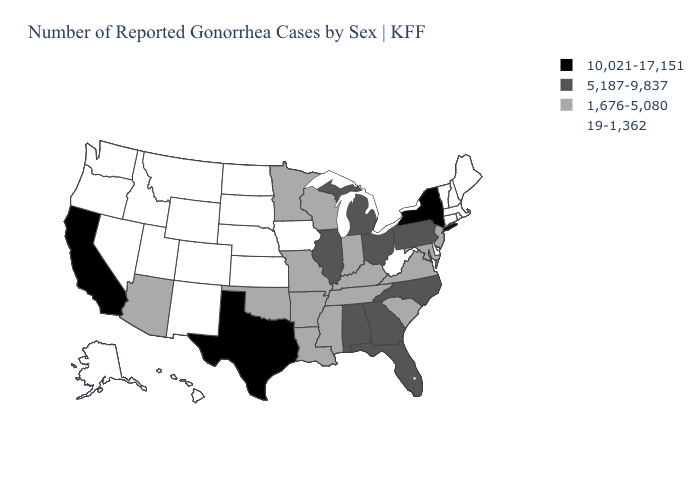Name the states that have a value in the range 1,676-5,080?
Concise answer only. Arizona, Arkansas, Indiana, Kentucky, Louisiana, Maryland, Minnesota, Mississippi, Missouri, New Jersey, Oklahoma, South Carolina, Tennessee, Virginia, Wisconsin. Does New York have the highest value in the USA?
Short answer required. Yes. Does Illinois have the highest value in the MidWest?
Concise answer only. Yes. Name the states that have a value in the range 5,187-9,837?
Concise answer only. Alabama, Florida, Georgia, Illinois, Michigan, North Carolina, Ohio, Pennsylvania. Name the states that have a value in the range 1,676-5,080?
Answer briefly. Arizona, Arkansas, Indiana, Kentucky, Louisiana, Maryland, Minnesota, Mississippi, Missouri, New Jersey, Oklahoma, South Carolina, Tennessee, Virginia, Wisconsin. What is the value of Alaska?
Short answer required. 19-1,362. What is the highest value in states that border Idaho?
Concise answer only. 19-1,362. Which states hav the highest value in the MidWest?
Answer briefly. Illinois, Michigan, Ohio. Which states have the highest value in the USA?
Short answer required. California, New York, Texas. Name the states that have a value in the range 10,021-17,151?
Quick response, please. California, New York, Texas. What is the highest value in the West ?
Be succinct. 10,021-17,151. Name the states that have a value in the range 19-1,362?
Keep it brief. Alaska, Colorado, Connecticut, Delaware, Hawaii, Idaho, Iowa, Kansas, Maine, Massachusetts, Montana, Nebraska, Nevada, New Hampshire, New Mexico, North Dakota, Oregon, Rhode Island, South Dakota, Utah, Vermont, Washington, West Virginia, Wyoming. What is the value of Pennsylvania?
Write a very short answer. 5,187-9,837. Name the states that have a value in the range 5,187-9,837?
Answer briefly. Alabama, Florida, Georgia, Illinois, Michigan, North Carolina, Ohio, Pennsylvania. 